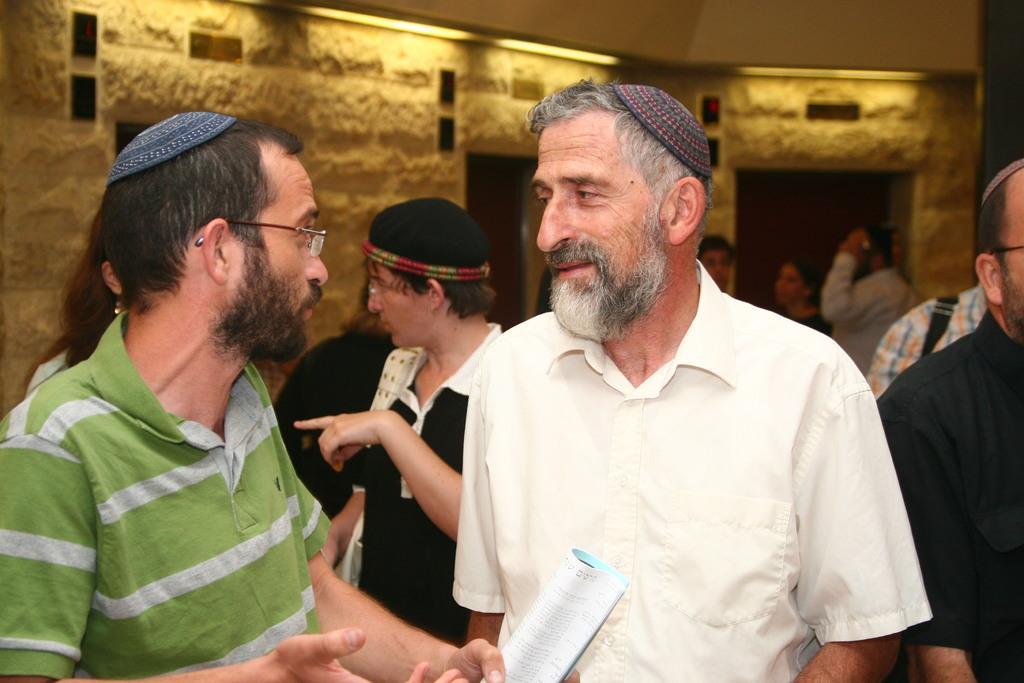Please provide a concise description of this image. As we can see in the image there are few people here and there, wall and lights. In the front there is a man holding a book. 